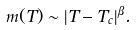Convert formula to latex. <formula><loc_0><loc_0><loc_500><loc_500>m ( T ) \sim | T - T _ { c } | ^ { \beta } .</formula> 